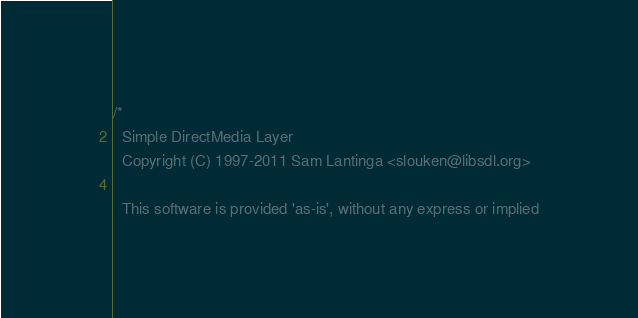<code> <loc_0><loc_0><loc_500><loc_500><_C_>/*
  Simple DirectMedia Layer
  Copyright (C) 1997-2011 Sam Lantinga <slouken@libsdl.org>

  This software is provided 'as-is', without any express or implied</code> 